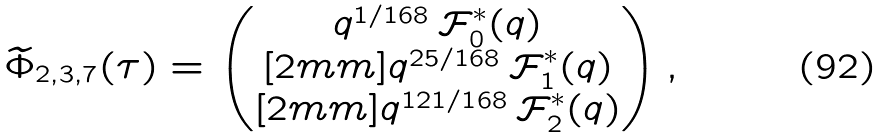Convert formula to latex. <formula><loc_0><loc_0><loc_500><loc_500>\widetilde { \Phi } _ { 2 , 3 , 7 } ( \tau ) = \begin{pmatrix} q ^ { 1 / 1 6 8 } \, \mathcal { F } _ { 0 } ^ { * } ( q ) \\ [ 2 m m ] q ^ { 2 5 / 1 6 8 } \, \mathcal { F } _ { 1 } ^ { * } ( q ) \\ [ 2 m m ] q ^ { 1 2 1 / 1 6 8 } \, \mathcal { F } _ { 2 } ^ { * } ( q ) \end{pmatrix} ,</formula> 